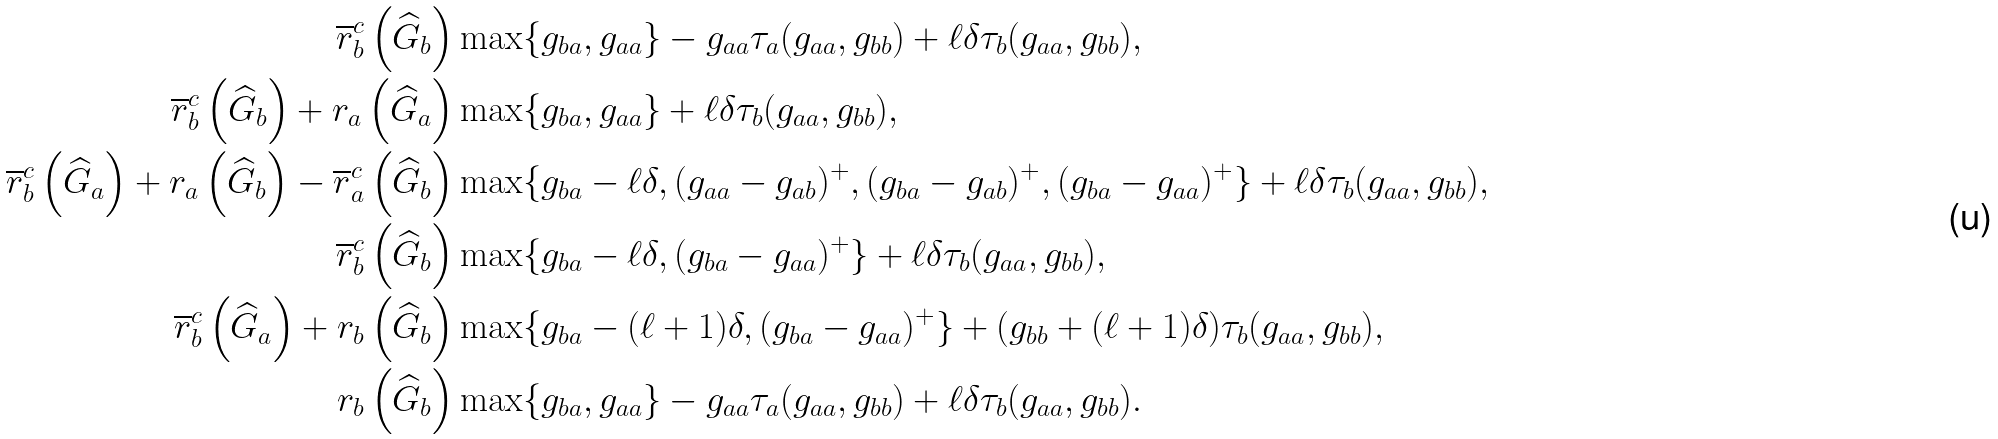<formula> <loc_0><loc_0><loc_500><loc_500>\overline { r } _ { b } ^ { c } \left ( \widehat { G } _ { b } \right ) & \max \{ g _ { b a } , g _ { a a } \} - g _ { a a } \tau _ { a } ( g _ { a a } , g _ { b b } ) + \ell \delta \tau _ { b } ( g _ { a a } , g _ { b b } ) , \\ \overline { r } _ { b } ^ { c } \left ( \widehat { G } _ { b } \right ) + r _ { a } \left ( \widehat { G } _ { a } \right ) & \max \{ g _ { b a } , g _ { a a } \} + \ell \delta \tau _ { b } ( g _ { a a } , g _ { b b } ) , \\ \overline { r } _ { b } ^ { c } \left ( \widehat { G } _ { a } \right ) + r _ { a } \left ( \widehat { G } _ { b } \right ) - \overline { r } _ { a } ^ { c } \left ( \widehat { G } _ { b } \right ) & \max \{ g _ { b a } - \ell \delta , ( g _ { a a } - g _ { a b } ) ^ { + } , ( g _ { b a } - g _ { a b } ) ^ { + } , ( g _ { b a } - g _ { a a } ) ^ { + } \} + \ell \delta \tau _ { b } ( g _ { a a } , g _ { b b } ) , \\ \overline { r } _ { b } ^ { c } \left ( \widehat { G } _ { b } \right ) & \max \{ g _ { b a } - \ell \delta , ( g _ { b a } - g _ { a a } ) ^ { + } \} + \ell \delta \tau _ { b } ( g _ { a a } , g _ { b b } ) , \\ \overline { r } _ { b } ^ { c } \left ( \widehat { G } _ { a } \right ) + r _ { b } \left ( \widehat { G } _ { b } \right ) & \max \{ g _ { b a } - ( \ell + 1 ) \delta , ( g _ { b a } - g _ { a a } ) ^ { + } \} + ( g _ { b b } + ( \ell + 1 ) \delta ) \tau _ { b } ( g _ { a a } , g _ { b b } ) , \\ r _ { b } \left ( \widehat { G } _ { b } \right ) & \max \{ g _ { b a } , g _ { a a } \} - g _ { a a } \tau _ { a } ( g _ { a a } , g _ { b b } ) + \ell \delta \tau _ { b } ( g _ { a a } , g _ { b b } ) .</formula> 